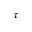Convert formula to latex. <formula><loc_0><loc_0><loc_500><loc_500>\tau</formula> 